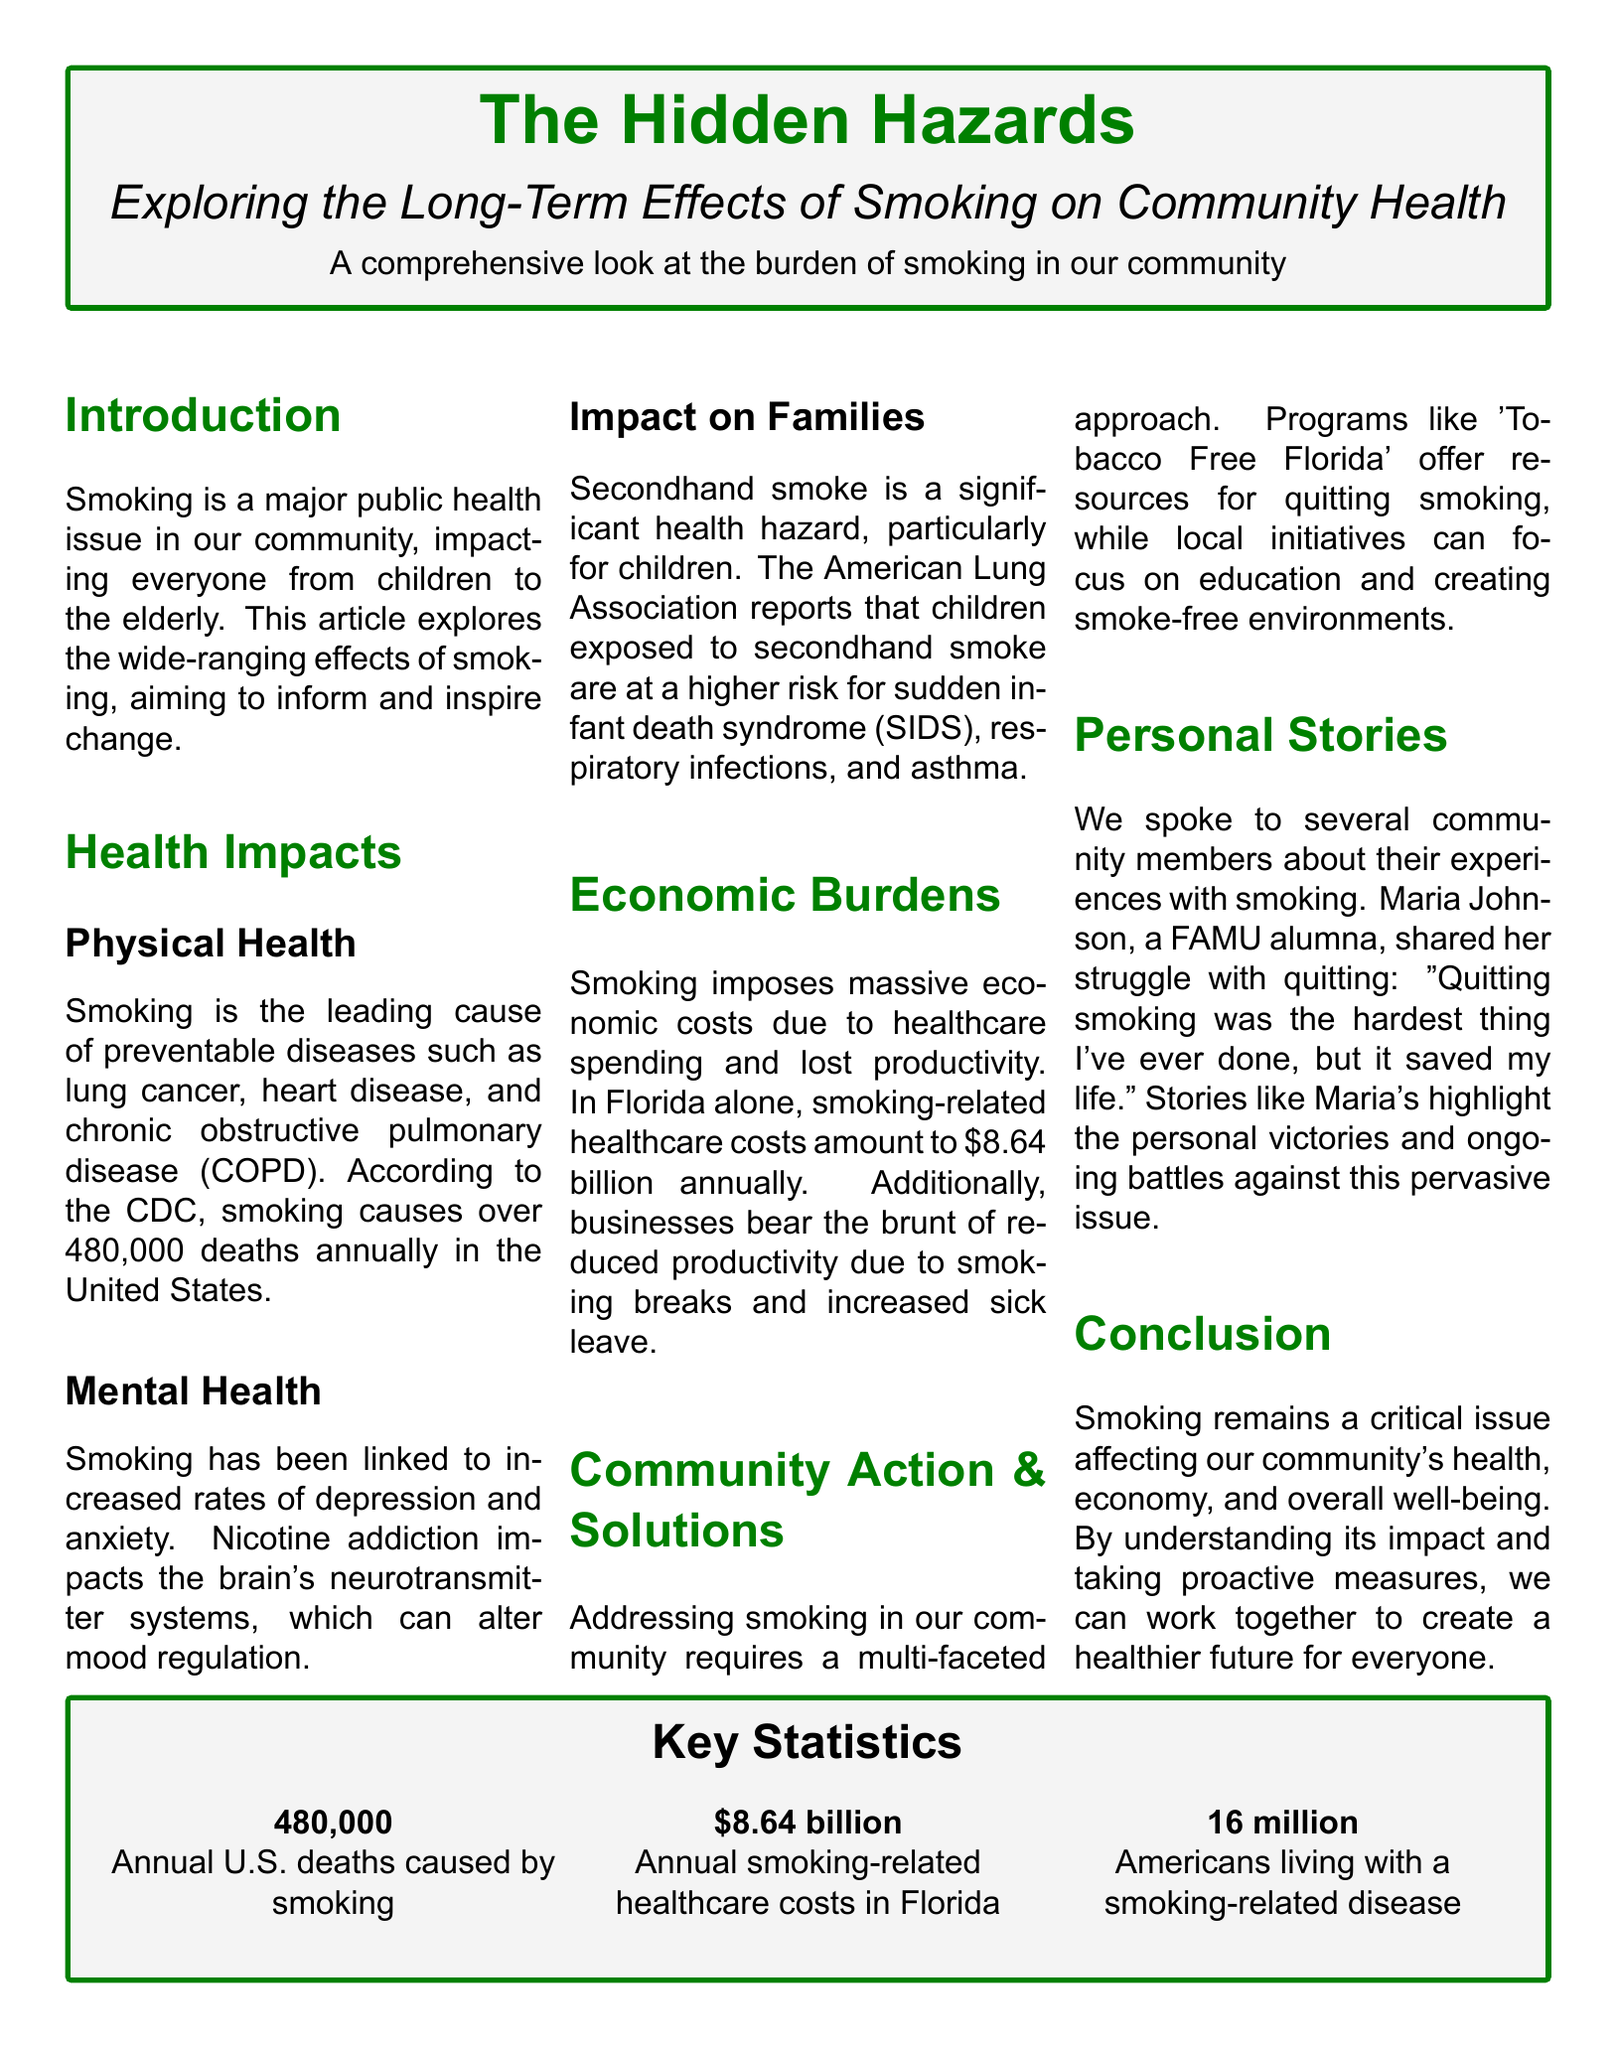What is the main topic of the article? The article focuses on the long-term effects of smoking on community health.
Answer: long-term effects of smoking on community health How many annual deaths in the U.S. are caused by smoking? The document states that smoking causes over 480,000 deaths annually in the U.S.
Answer: 480,000 What is the annual smoking-related healthcare cost in Florida? The document mentions that smoking-related healthcare costs in Florida amount to $8.64 billion annually.
Answer: $8.64 billion Who shared her struggle with quitting smoking? The article includes a personal story from Maria Johnson about her struggle with quitting smoking.
Answer: Maria Johnson What major mental health issue is associated with smoking? Increased rates of depression and anxiety are linked to smoking, as noted in the document.
Answer: depression and anxiety What organization offers resources for quitting smoking? The document refers to 'Tobacco Free Florida' as a program providing quitting resources.
Answer: Tobacco Free Florida What is one health risk for children exposed to secondhand smoke? The document indicates that children exposed to secondhand smoke are at a higher risk for sudden infant death syndrome (SIDS).
Answer: sudden infant death syndrome (SIDS) What percentage of Americans live with a smoking-related disease? The document does not provide a percentage, but states that 16 million Americans live with a smoking-related disease.
Answer: 16 million 